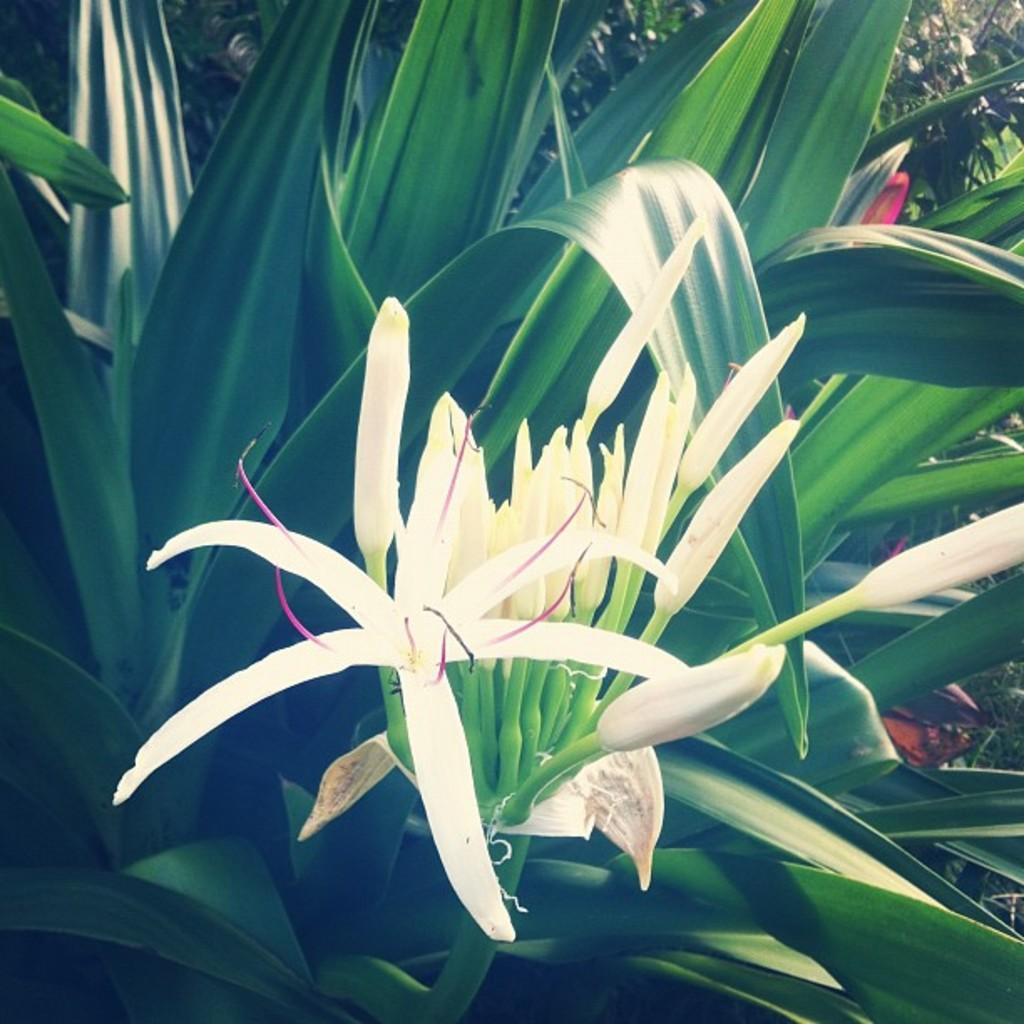What type of flowers can be seen in the image? There are white flowers in the image. What else is present in the image besides the flowers? There are leaves in the image. How many kittens are playing with a tooth in the image? There are no kittens or tooth present in the image; it only features white flowers and leaves. 